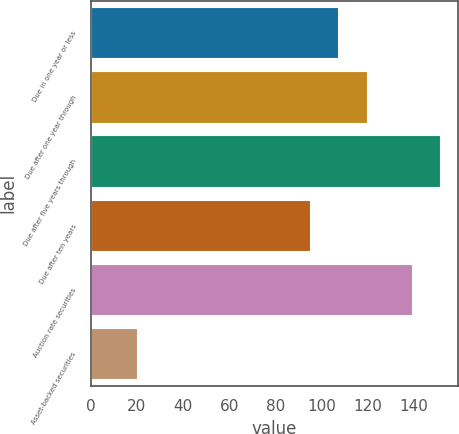Convert chart. <chart><loc_0><loc_0><loc_500><loc_500><bar_chart><fcel>Due in one year or less<fcel>Due after one year through<fcel>Due after five years through<fcel>Due after ten years<fcel>Auction rate securities<fcel>Asset-backed securities<nl><fcel>107.3<fcel>119.6<fcel>151.3<fcel>95<fcel>139<fcel>20<nl></chart> 